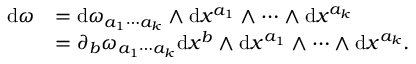Convert formula to latex. <formula><loc_0><loc_0><loc_500><loc_500>\begin{array} { r l } { d \omega } & { = d \omega _ { a _ { 1 } \cdots a _ { k } } \wedge d x ^ { a _ { 1 } } \wedge \cdots \wedge d x ^ { a _ { k } } } \\ & { = \partial _ { b } \omega _ { a _ { 1 } \cdots a _ { k } } d x ^ { b } \wedge d x ^ { a _ { 1 } } \wedge \cdots \wedge d x ^ { a _ { k } } . } \end{array}</formula> 